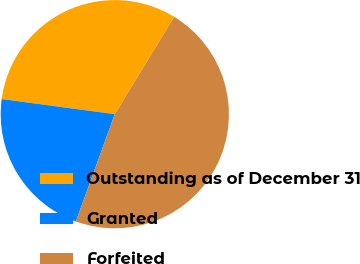Convert chart. <chart><loc_0><loc_0><loc_500><loc_500><pie_chart><fcel>Outstanding as of December 31<fcel>Granted<fcel>Forfeited<nl><fcel>31.61%<fcel>21.58%<fcel>46.81%<nl></chart> 